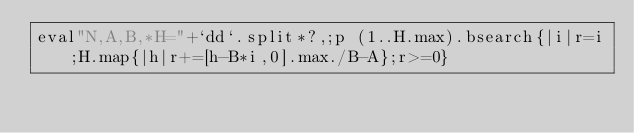Convert code to text. <code><loc_0><loc_0><loc_500><loc_500><_Ruby_>eval"N,A,B,*H="+`dd`.split*?,;p (1..H.max).bsearch{|i|r=i;H.map{|h|r+=[h-B*i,0].max./B-A};r>=0}</code> 